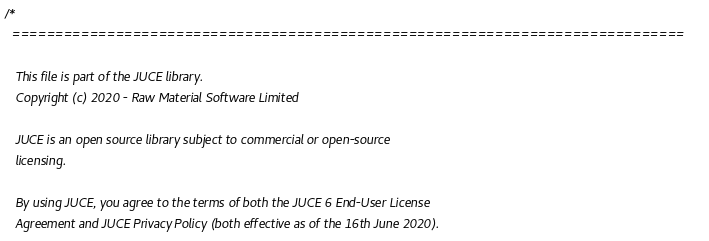Convert code to text. <code><loc_0><loc_0><loc_500><loc_500><_ObjectiveC_>/*
  ==============================================================================

   This file is part of the JUCE library.
   Copyright (c) 2020 - Raw Material Software Limited

   JUCE is an open source library subject to commercial or open-source
   licensing.

   By using JUCE, you agree to the terms of both the JUCE 6 End-User License
   Agreement and JUCE Privacy Policy (both effective as of the 16th June 2020).
</code> 